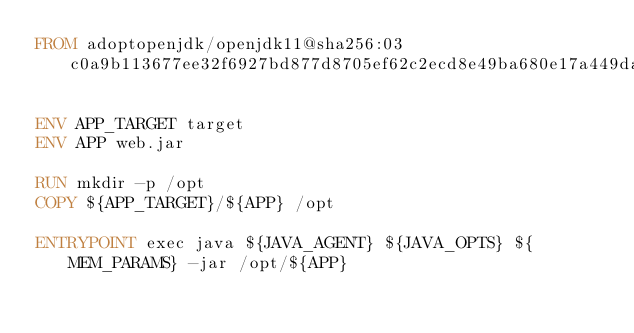Convert code to text. <code><loc_0><loc_0><loc_500><loc_500><_Dockerfile_>FROM adoptopenjdk/openjdk11@sha256:03c0a9b113677ee32f6927bd877d8705ef62c2ecd8e49ba680e17a449da5ccf3

ENV APP_TARGET target
ENV APP web.jar

RUN mkdir -p /opt
COPY ${APP_TARGET}/${APP} /opt

ENTRYPOINT exec java ${JAVA_AGENT} ${JAVA_OPTS} ${MEM_PARAMS} -jar /opt/${APP}
</code> 